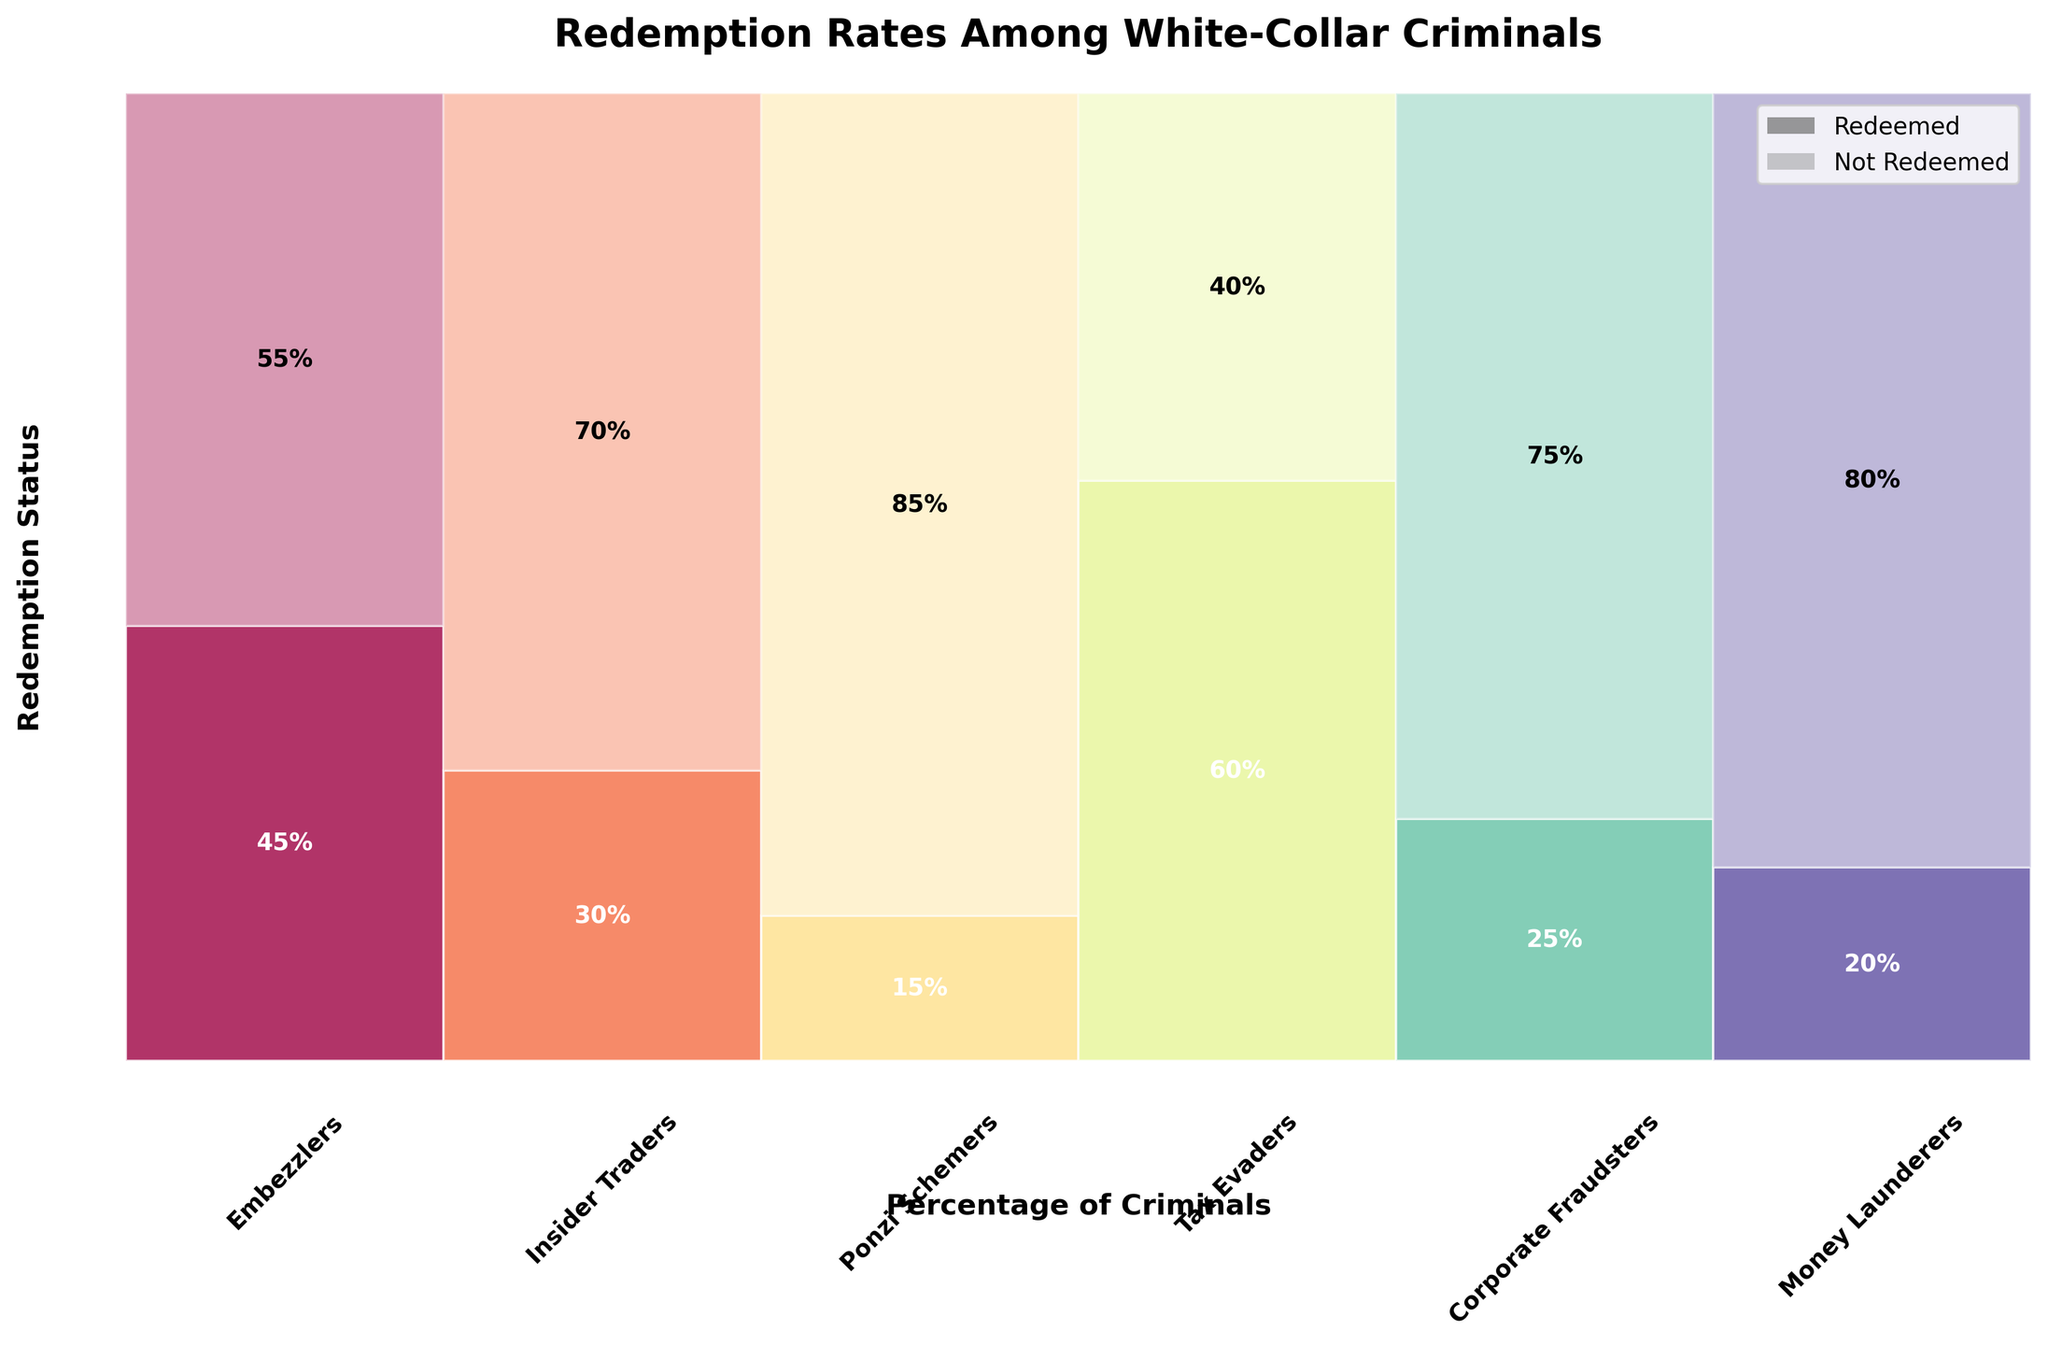What's the title of the plot? The title is usually located at the top of the plot. In this case, it's "Redemption Rates Among White-Collar Criminals," which summarizes what the plot is about.
Answer: Redemption Rates Among White-Collar Criminals What color shades represent "Redeemed" and "Not Redeemed"? The plot uses a color scheme where a more opaque shade represents "Redeemed" and a lighter shade of the same color represents "Not Redeemed." This is usually indicated by the legend in the upper right corner.
Answer: Opaque and lighter shades of gray Which type of white-collar criminal has the highest redemption rate? To determine this, look for the rectangle segment at the bottom, which represents redeemed individuals. Tax Evaders have the tallest segment, indicating the highest redemption rate of 60%.
Answer: Tax Evaders Which type of white-collar criminals have lower than 30% redemption rates? Examine the segments at the bottom part of the plot for each type of criminal. Ponzi Schemers, Corporate Fraudsters, and Money Launderers have lower than 30% redemption rates, indicated by shorter segments.
Answer: Ponzi Schemers, Corporate Fraudsters, Money Launderers How do the redemption rates of Embezzlers and Insider Traders compare? Embezzlers have a 45% redemption rate, and Insider Traders have a 30% redemption rate. So, Embezzlers have a higher redemption rate than Insider Traders.
Answer: Embezzlers have a higher redemption rate What is the difference in the number of redeemed individuals between Ponzi Schemers and Tax Evaders? Ponzi Schemers have 15 redeemed individuals, while Tax Evaders have 60. The difference is 60 - 15 = 45.
Answer: 45 Which type has the highest percentage of not redeemed individuals? Look for the tallest rectangle segment at the upper part of the plot. Ponzi Schemers, with 85% not redeemed, have the highest percentage in this case.
Answer: Ponzi Schemers What percentage of Corporate Fraudsters are not redeemed? Look for the segment that represents "Not Redeemed" for Corporate Fraudsters. It constitutes 75% of the total Corporate Fraudsters.
Answer: 75% How many total types of white-collar criminals are shown in the plot? By counting the different categories listed along the x-axis, we find there are six types of white-collar criminals in the plot.
Answer: 6 If you sum the redemption rates of Money Launderers and Tax Evaders, what is the result? Money Launderers have a 20% redemption rate, and Tax Evaders have 60%. The sum is 20% + 60% = 80%.
Answer: 80% 